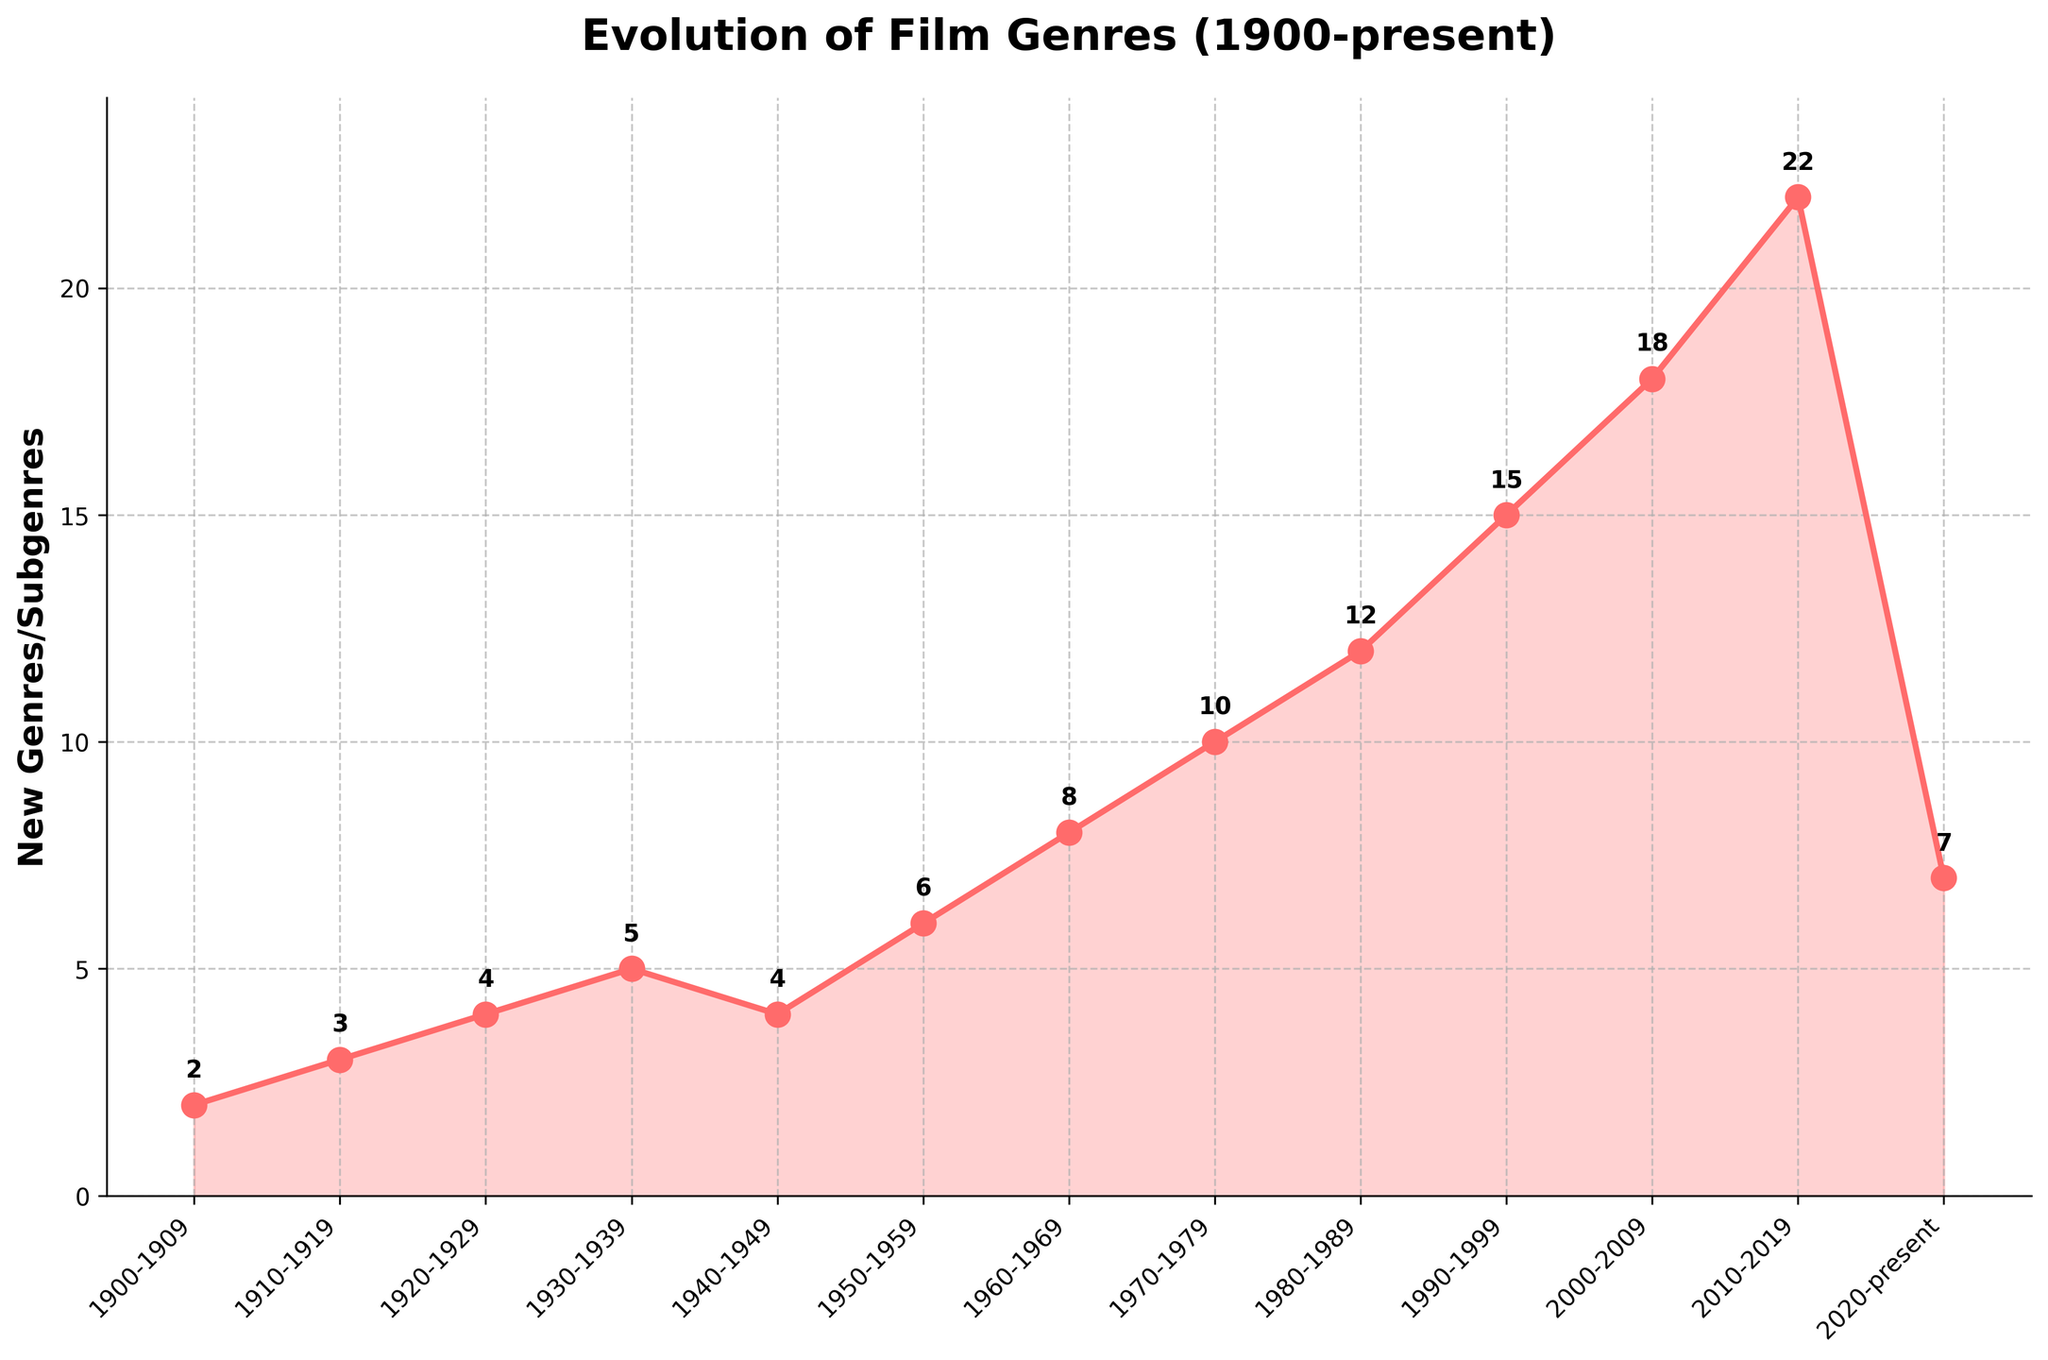How many new genres or subgenres emerged in the 2010-2019 decade? Look at the data point corresponding to the 2010-2019 decade on the x-axis and read its value on the y-axis.
Answer: 22 Which decade saw the highest number of new genres or subgenres emerging? Identify the highest point on the line chart and match it with the corresponding decade on the x-axis.
Answer: 2010-2019 What's the difference in the number of new genres or subgenres between the 1970-1979 and 2000-2009 decades? Find the y-values for the 1970-1979 and 2000-2009 decades and subtract the former from the latter (18 - 10).
Answer: 8 How many more new genres or subgenres emerged in the 1980-1989 decade compared to the 1940-1949 decade? Find the difference between the y-values for the 1980-1989 and 1940-1949 decades (12 - 4).
Answer: 8 During which decade did the number of new genres or subgenres emerging first exceed 10? Identify the first data point on the chart where the y-value is greater than 10, and match it with the corresponding decade on the x-axis.
Answer: 1980-1989 What overall trend can you observe from 1900 to 2010 in the frequency of new genres or subgenres emerging? Observe the general direction of the line from 1900 to 2010. Note that it is increasing steadily over time, indicating a rising trend.
Answer: Increasing By how much did the number of new genres or subgenres emerging change from 2010-2019 to 2020-present? Find the y-values for the 2010-2019 and 2020-present decades and subtract the latter from the former (22 - 7).
Answer: 15 How many times did the frequency of new genres or subgenres not show an increase from one decade to the next? Identify the points where the frequency either remained the same or decreased relative to the previous decade. This happened once, from 1940-1949 to 1950-1959 (4 to 4).
Answer: 1 What is the average number of new genres or subgenres emerging per decade from 1900 to 2019? Sum the y-values for all decades from 1900 to 2019 and divide by the number of decades (2+3+4+5+4+6+8+10+12+15+18+22)/12.
Answer: 9.25 